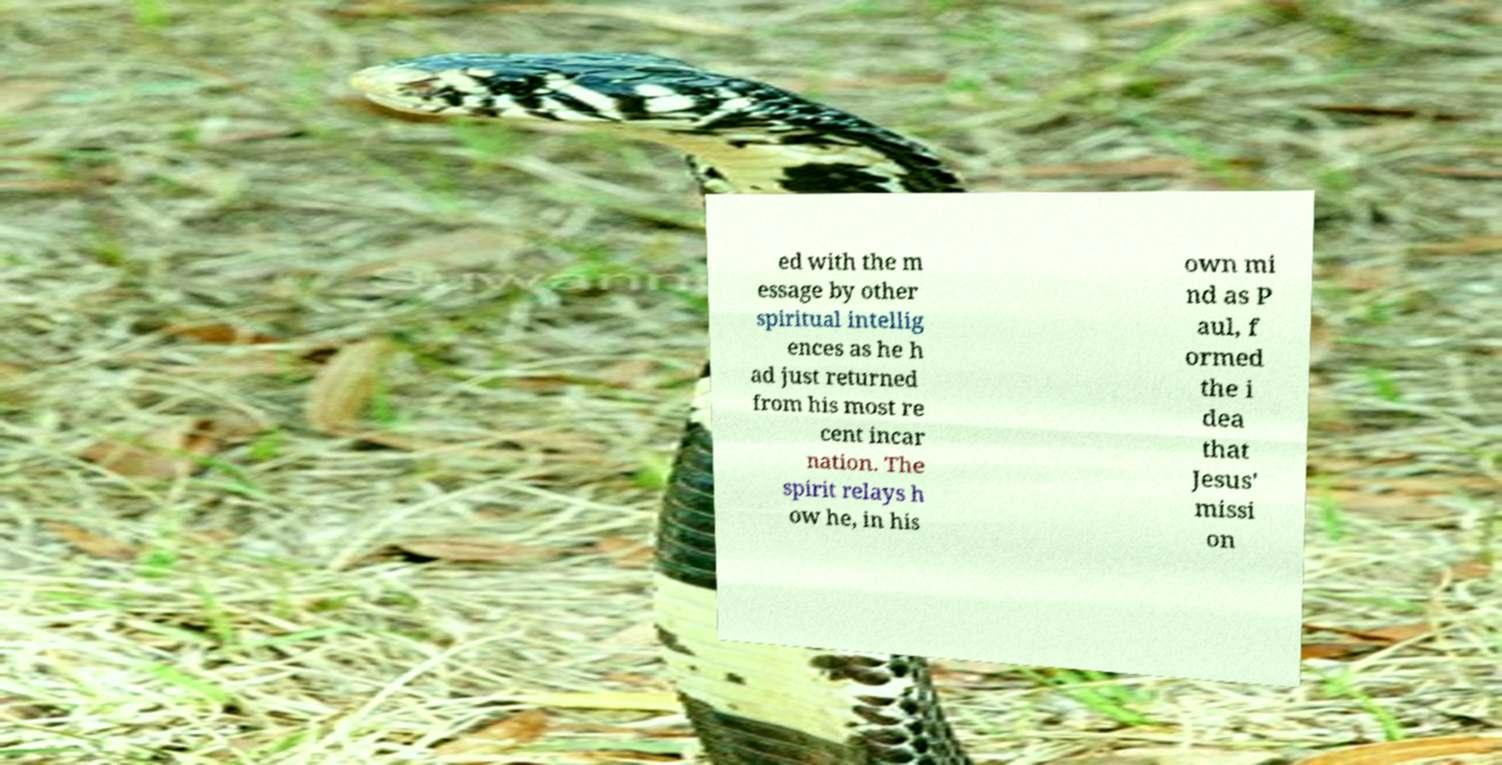Please identify and transcribe the text found in this image. ed with the m essage by other spiritual intellig ences as he h ad just returned from his most re cent incar nation. The spirit relays h ow he, in his own mi nd as P aul, f ormed the i dea that Jesus' missi on 